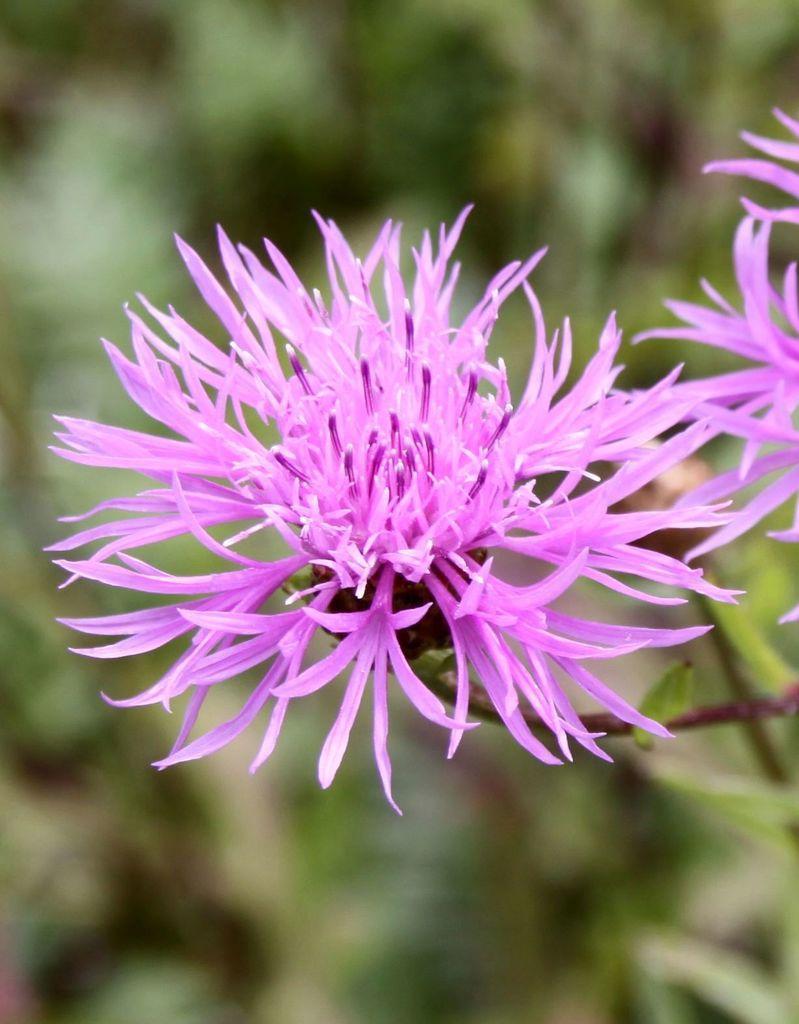How would you summarize this image in a sentence or two? In this image we can see flowers on stems. In the background it is blur. 